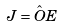<formula> <loc_0><loc_0><loc_500><loc_500>J = \hat { O } E</formula> 